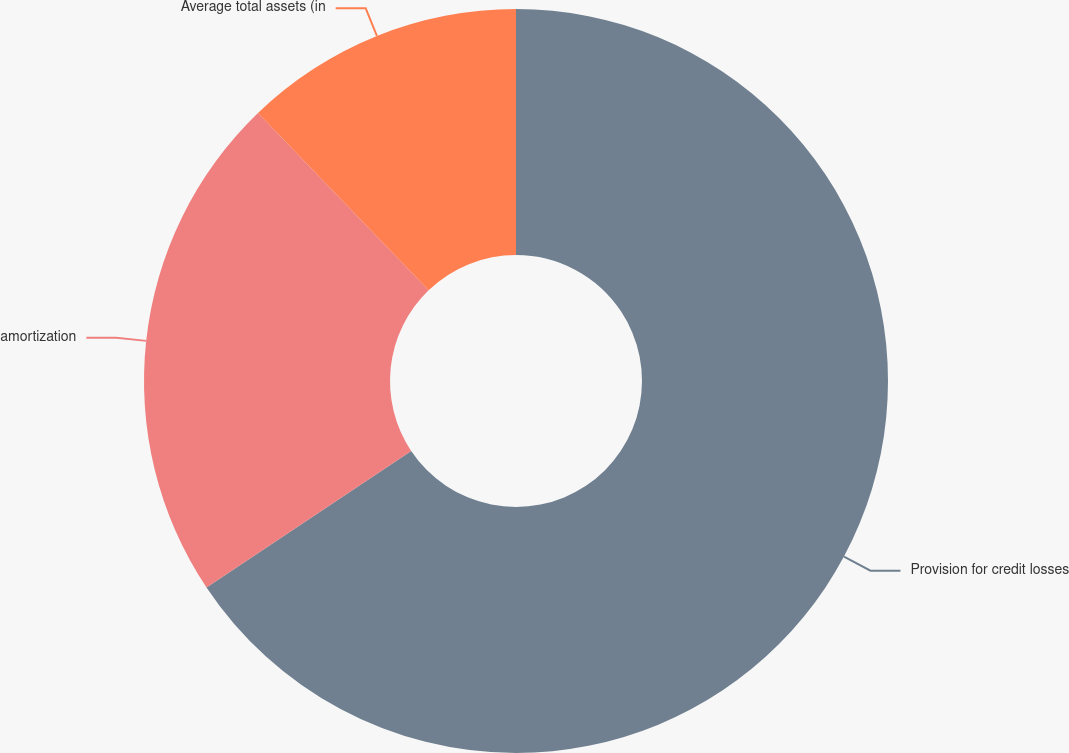<chart> <loc_0><loc_0><loc_500><loc_500><pie_chart><fcel>Provision for credit losses<fcel>amortization<fcel>Average total assets (in<nl><fcel>65.64%<fcel>22.16%<fcel>12.2%<nl></chart> 